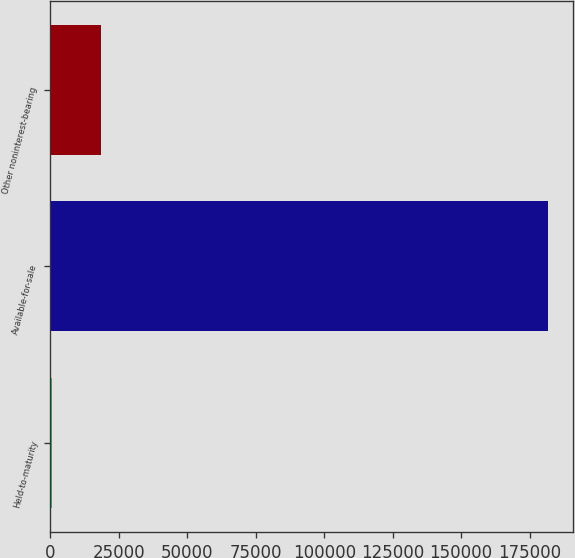Convert chart. <chart><loc_0><loc_0><loc_500><loc_500><bar_chart><fcel>Held-to-maturity<fcel>Available-for-sale<fcel>Other noninterest-bearing<nl><fcel>403<fcel>181591<fcel>18521.8<nl></chart> 